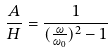<formula> <loc_0><loc_0><loc_500><loc_500>\frac { A } { H } = \frac { 1 } { ( \frac { \omega } { \omega _ { 0 } } ) ^ { 2 } - 1 }</formula> 